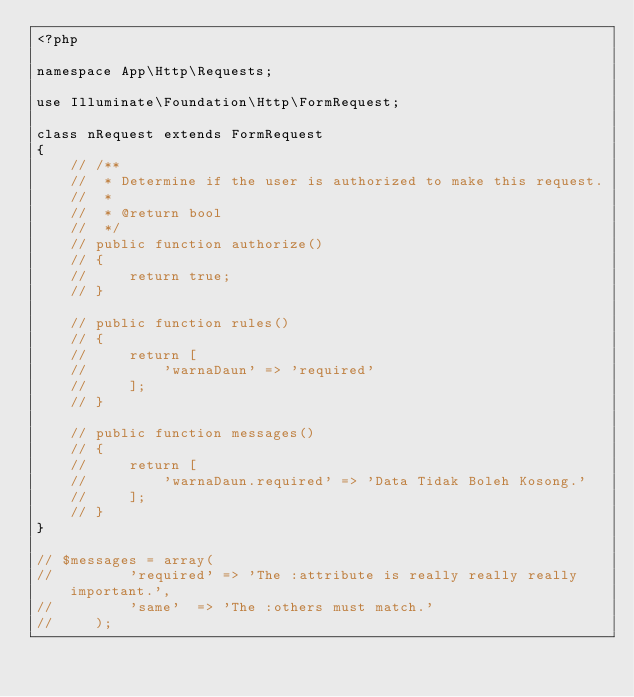<code> <loc_0><loc_0><loc_500><loc_500><_PHP_><?php

namespace App\Http\Requests;

use Illuminate\Foundation\Http\FormRequest;

class nRequest extends FormRequest
{
    // /**
    //  * Determine if the user is authorized to make this request.
    //  *
    //  * @return bool
    //  */
    // public function authorize()
    // {
    //     return true;
    // }

    // public function rules()
    // {
    //     return [
    //         'warnaDaun' => 'required'
    //     ];
    // }

    // public function messages()
    // {
    //     return [
    //         'warnaDaun.required' => 'Data Tidak Boleh Kosong.'
    //     ];
    // }
}

// $messages = array(
//         'required' => 'The :attribute is really really really important.',
//         'same'  => 'The :others must match.'
//     );</code> 